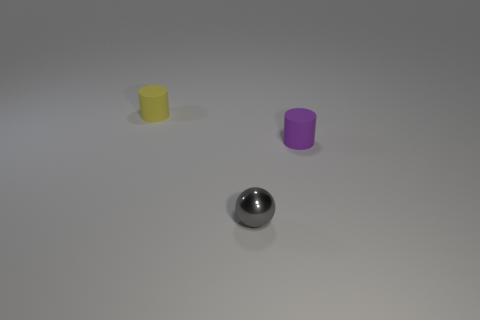Are there any tiny gray balls left of the small yellow cylinder?
Keep it short and to the point. No. What number of green things are cylinders or balls?
Your answer should be very brief. 0. Are there any other objects that have the same size as the gray object?
Offer a very short reply. Yes. What material is the yellow object that is the same size as the gray thing?
Ensure brevity in your answer.  Rubber. How many objects are either metal balls or tiny spheres right of the tiny yellow thing?
Provide a succinct answer. 1. Are there any other tiny matte things of the same shape as the small yellow rubber object?
Offer a very short reply. Yes. What number of matte things are either small purple cylinders or large yellow balls?
Your response must be concise. 1. How many cylinders are there?
Offer a terse response. 2. Is the object that is behind the small purple thing made of the same material as the tiny cylinder that is right of the yellow cylinder?
Keep it short and to the point. Yes. What color is the other matte thing that is the same shape as the yellow thing?
Give a very brief answer. Purple. 